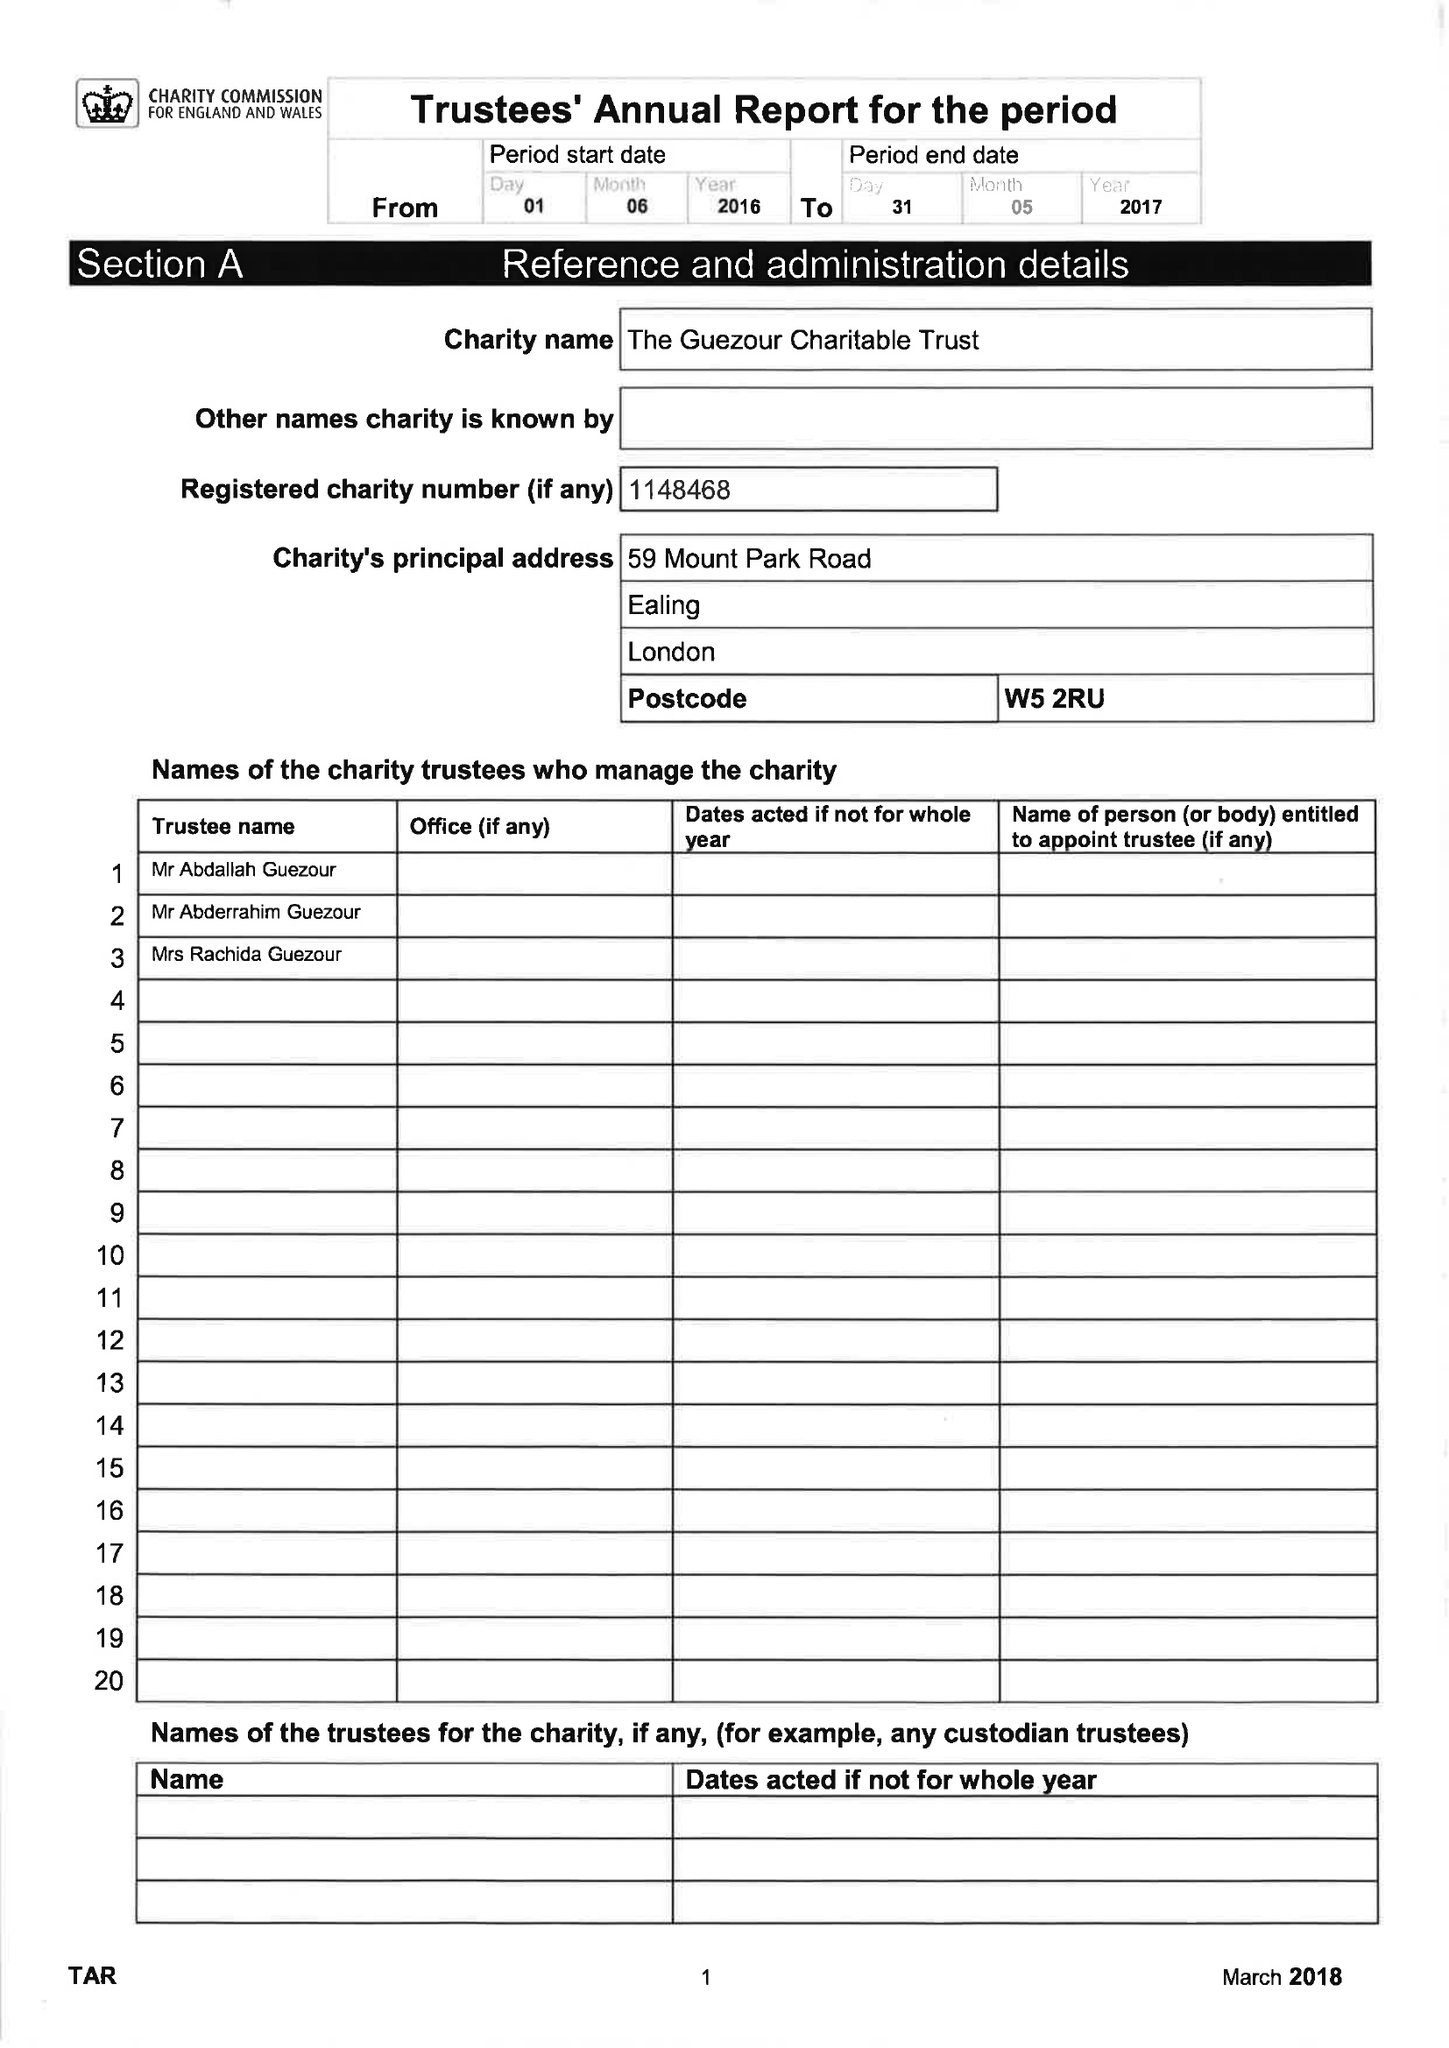What is the value for the address__postcode?
Answer the question using a single word or phrase. W5 2RU 